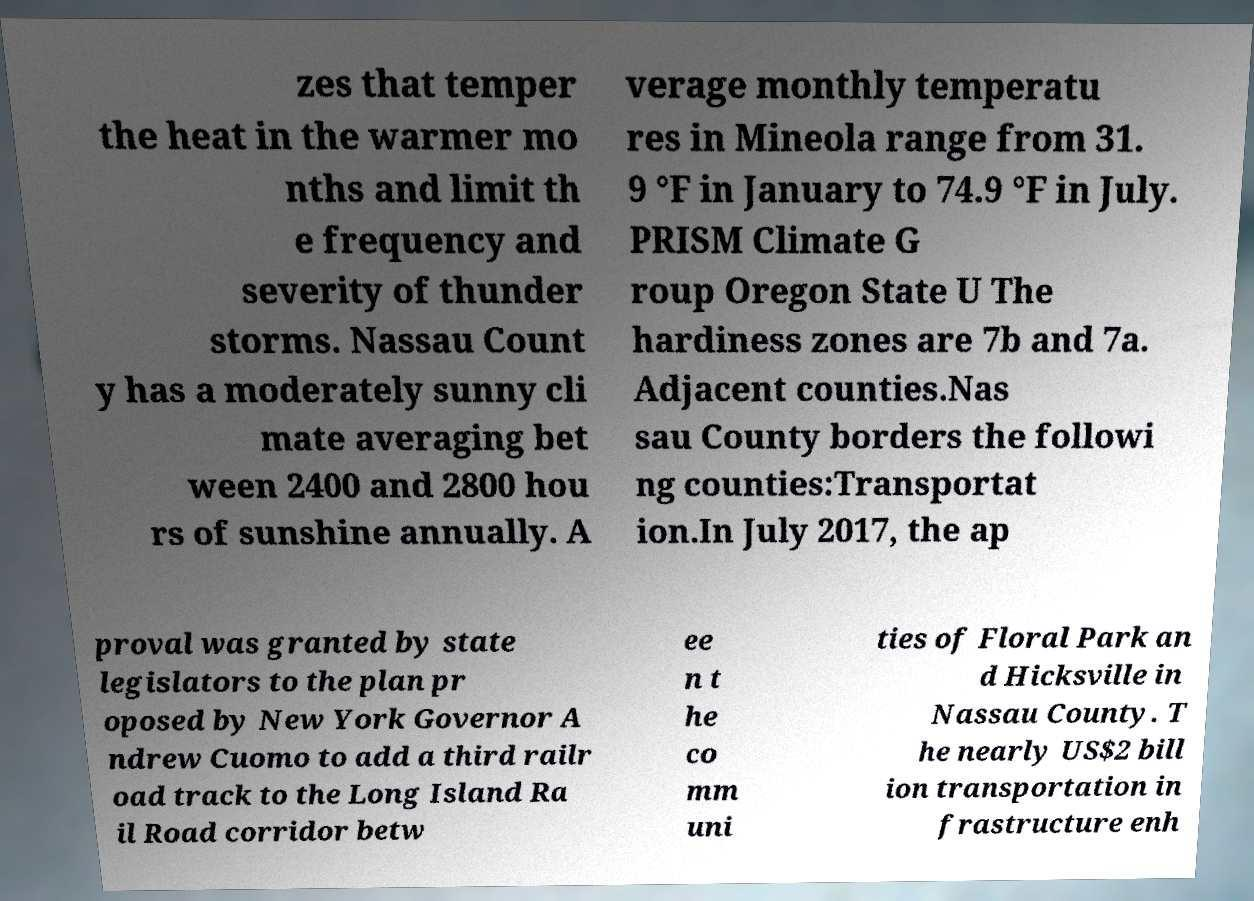I need the written content from this picture converted into text. Can you do that? zes that temper the heat in the warmer mo nths and limit th e frequency and severity of thunder storms. Nassau Count y has a moderately sunny cli mate averaging bet ween 2400 and 2800 hou rs of sunshine annually. A verage monthly temperatu res in Mineola range from 31. 9 °F in January to 74.9 °F in July. PRISM Climate G roup Oregon State U The hardiness zones are 7b and 7a. Adjacent counties.Nas sau County borders the followi ng counties:Transportat ion.In July 2017, the ap proval was granted by state legislators to the plan pr oposed by New York Governor A ndrew Cuomo to add a third railr oad track to the Long Island Ra il Road corridor betw ee n t he co mm uni ties of Floral Park an d Hicksville in Nassau County. T he nearly US$2 bill ion transportation in frastructure enh 